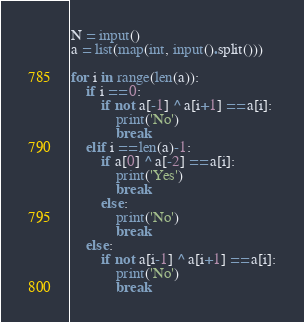<code> <loc_0><loc_0><loc_500><loc_500><_Python_>N = input()
a = list(map(int, input().split()))

for i in range(len(a)):
    if i == 0:
        if not a[-1] ^ a[i+1] == a[i]:
            print('No')
            break
    elif i == len(a)-1:
        if a[0] ^ a[-2] == a[i]:
            print('Yes')
            break
        else:
            print('No')
            break
    else:
        if not a[i-1] ^ a[i+1] == a[i]:
            print('No')
            break</code> 